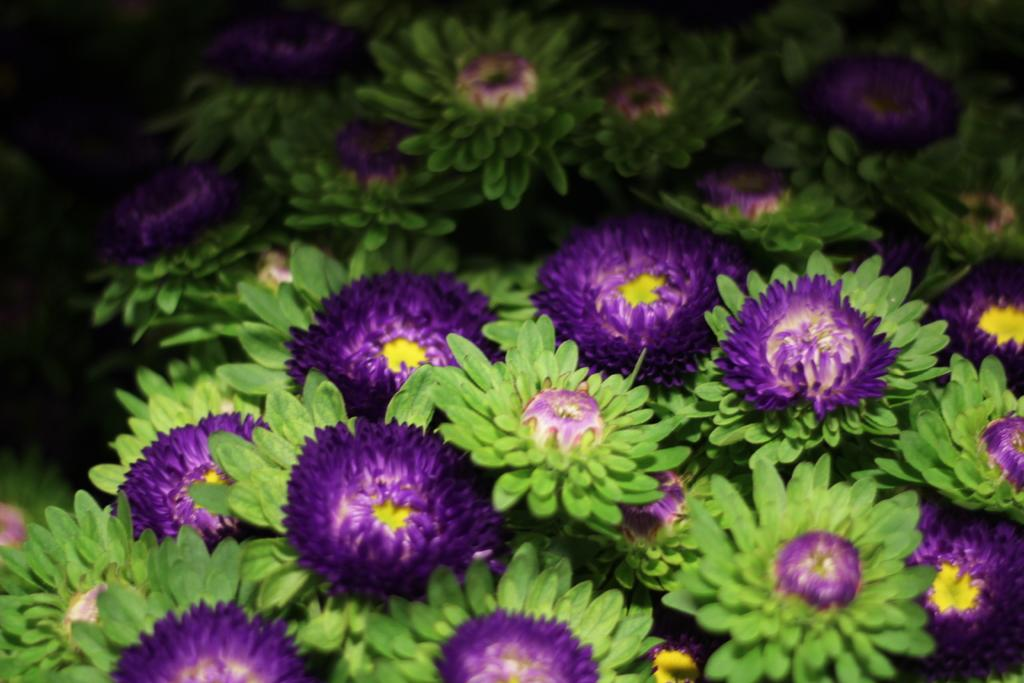What type of flowers can be seen in the foreground of the image? There are violet color flowers in the foreground of the image. What is the growth stage of some of the flowers in the image? There are buds in the foreground of the image. What color are the leaves in the foreground of the image? There are green leaves in the foreground of the image. Can you see a pipe emitting hot steam in the image? There is no pipe or hot steam present in the image. Is there any magic happening in the image? There is no indication of magic or any magical elements in the image. 